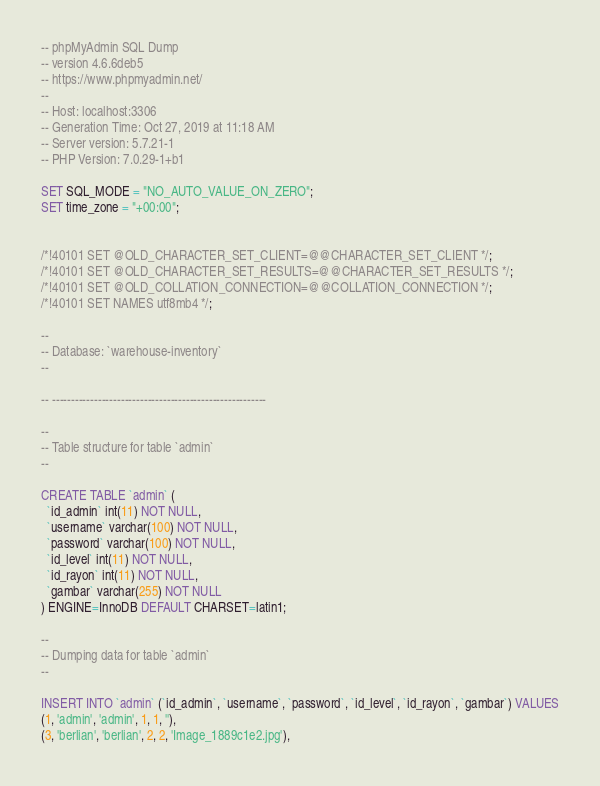<code> <loc_0><loc_0><loc_500><loc_500><_SQL_>-- phpMyAdmin SQL Dump
-- version 4.6.6deb5
-- https://www.phpmyadmin.net/
--
-- Host: localhost:3306
-- Generation Time: Oct 27, 2019 at 11:18 AM
-- Server version: 5.7.21-1
-- PHP Version: 7.0.29-1+b1

SET SQL_MODE = "NO_AUTO_VALUE_ON_ZERO";
SET time_zone = "+00:00";


/*!40101 SET @OLD_CHARACTER_SET_CLIENT=@@CHARACTER_SET_CLIENT */;
/*!40101 SET @OLD_CHARACTER_SET_RESULTS=@@CHARACTER_SET_RESULTS */;
/*!40101 SET @OLD_COLLATION_CONNECTION=@@COLLATION_CONNECTION */;
/*!40101 SET NAMES utf8mb4 */;

--
-- Database: `warehouse-inventory`
--

-- --------------------------------------------------------

--
-- Table structure for table `admin`
--

CREATE TABLE `admin` (
  `id_admin` int(11) NOT NULL,
  `username` varchar(100) NOT NULL,
  `password` varchar(100) NOT NULL,
  `id_level` int(11) NOT NULL,
  `id_rayon` int(11) NOT NULL,
  `gambar` varchar(255) NOT NULL
) ENGINE=InnoDB DEFAULT CHARSET=latin1;

--
-- Dumping data for table `admin`
--

INSERT INTO `admin` (`id_admin`, `username`, `password`, `id_level`, `id_rayon`, `gambar`) VALUES
(1, 'admin', 'admin', 1, 1, ''),
(3, 'berlian', 'berlian', 2, 2, 'Image_1889c1e2.jpg'),</code> 